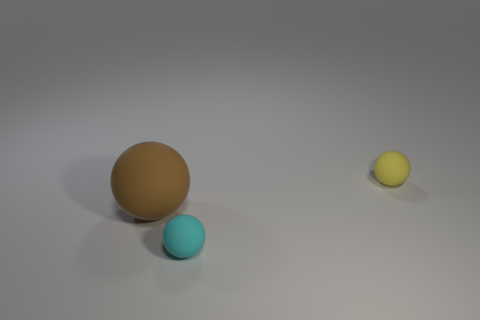Add 2 small cyan metallic cylinders. How many objects exist? 5 Add 2 brown metal blocks. How many brown metal blocks exist? 2 Subtract 0 red cylinders. How many objects are left? 3 Subtract all large purple things. Subtract all small things. How many objects are left? 1 Add 2 large brown matte things. How many large brown matte things are left? 3 